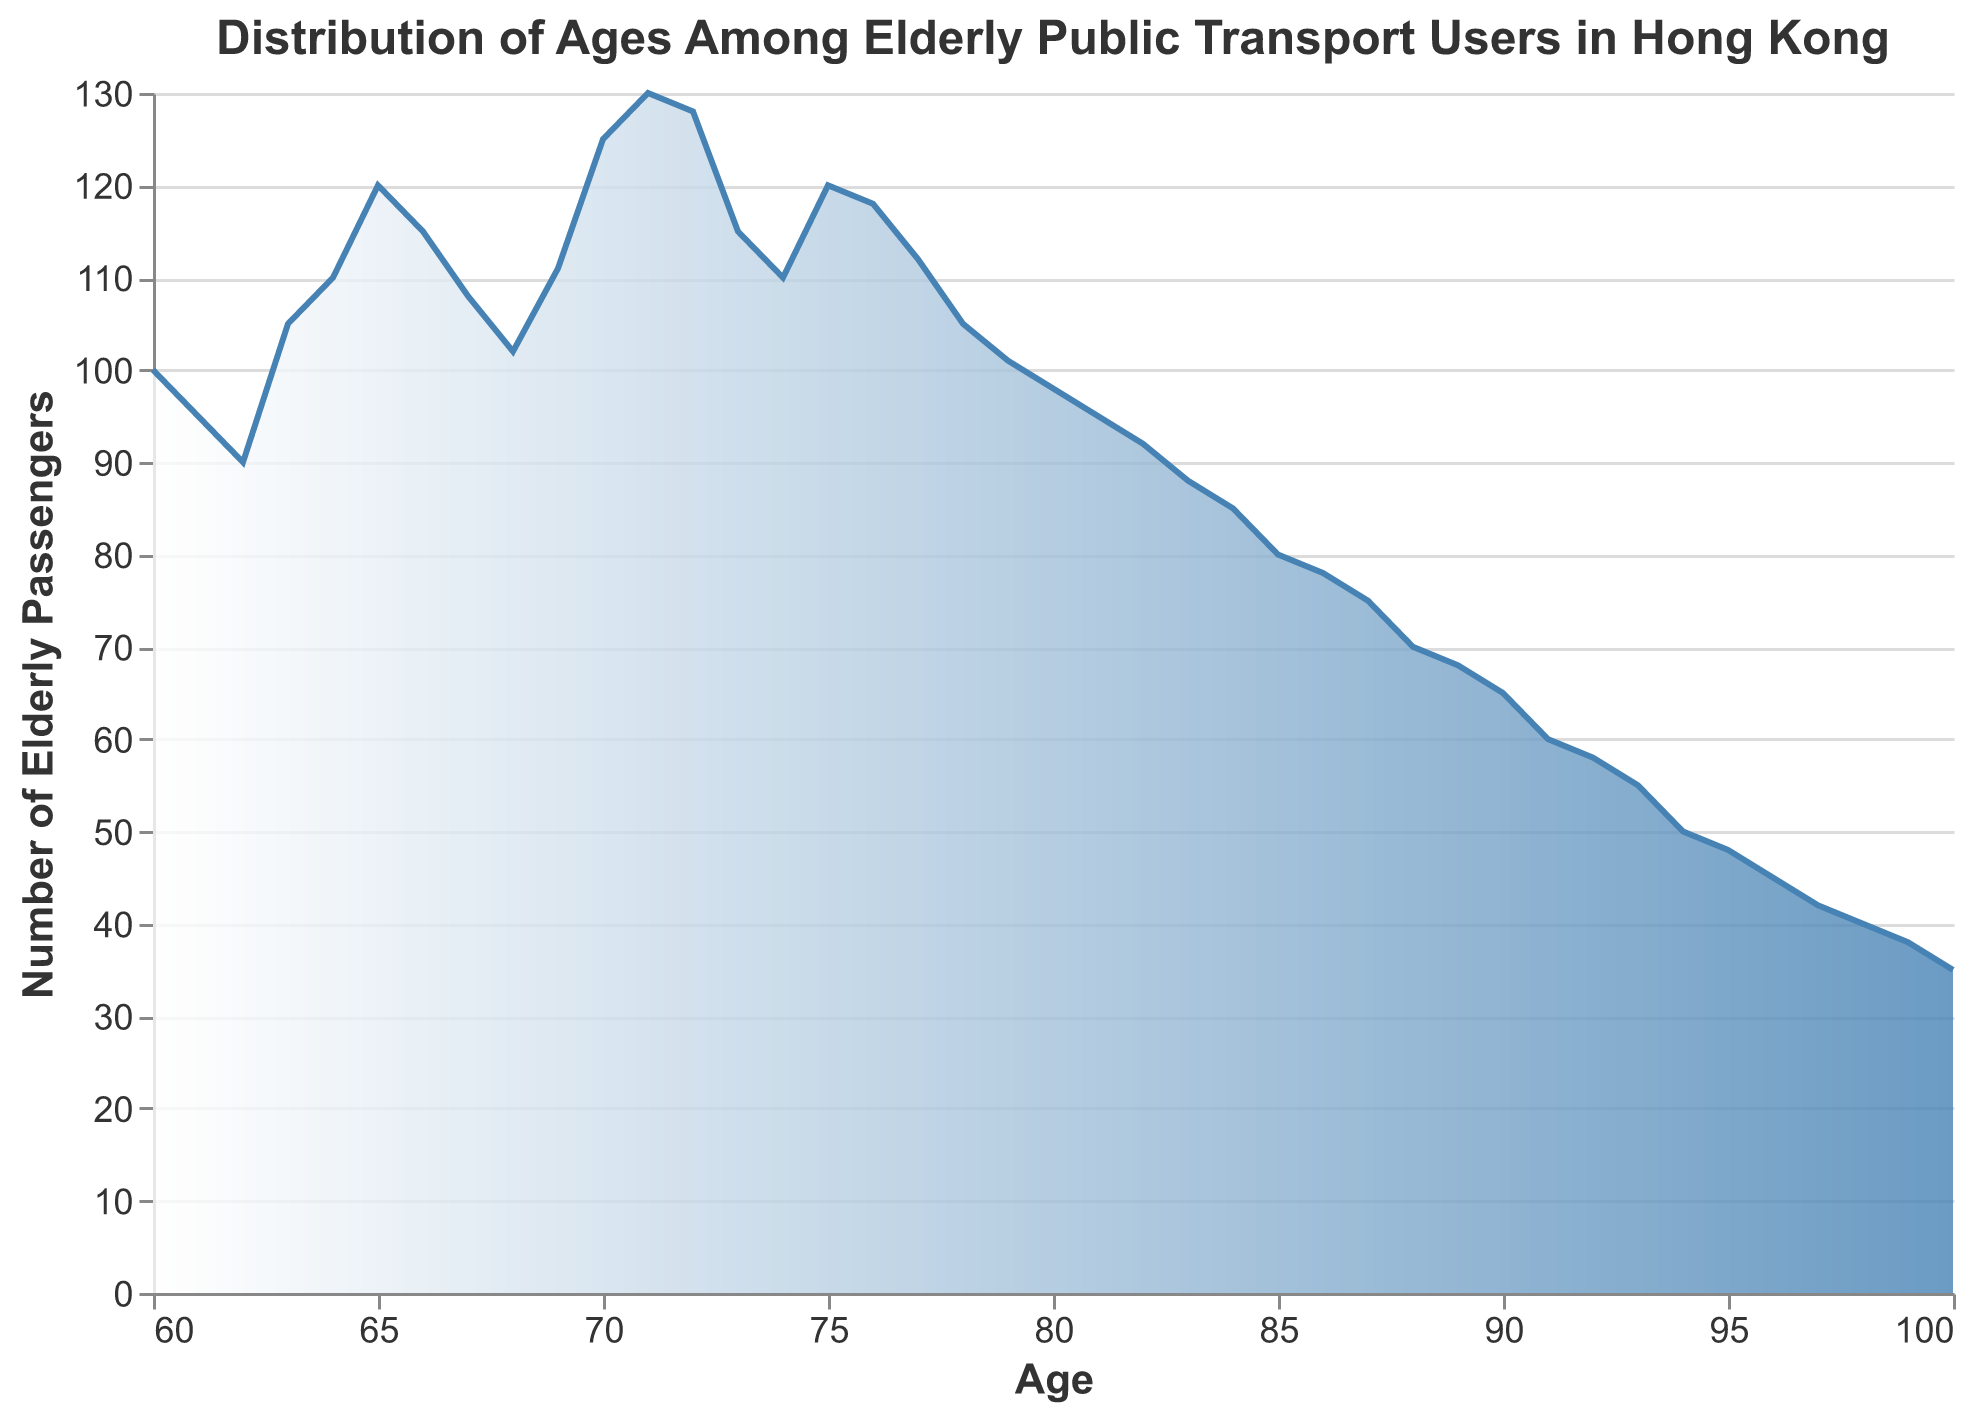What is the title of the plot? The title of the plot is written at the top and serves as a summary of what the plot illustrates.
Answer: Distribution of Ages Among Elderly Public Transport Users in Hong Kong What is the age range of elderly passengers in the plot? The x-axis represents the age of elderly passengers. The minimum value is 60, and the maximum value is 100.
Answer: 60 to 100 Which age group has the highest number of elderly passengers using public transportation? By observing the peak of the density curve on the y-axis, we can see the age group with the highest number of passengers.
Answer: 71 At what age does the number of elderly passengers first fall below 60? The number of elderly passengers is shown on the y-axis. Locate the point where it falls below 60 on the curve corresponds to the age on the x-axis.
Answer: 91 How many elderly passengers are there at the age of 80? Find the age 80 on the x-axis and locate the corresponding value on the y-axis.
Answer: 98 Which age group has fewer than 50 elderly passengers using public transport for the first time? Find the point on the curve where the number of elderly passengers first drops below 50. The x-axis value at this point indicates the age group.
Answer: 93 How does the number of passengers change as age increases from 60 to 71? Examine the shape of the density curve from age 60 to 71. Notice whether the curve rises or falls.
Answer: It increases steadily, reaching a peak at 71 What is the average number of elderly passengers between age 65 and 75? Calculate the sum of the number of passengers from age 65 to age 75 and divide by the number of age points (11).
Answer: 118.72 Compare the number of elderly passengers at age 70 and age 90. Look at the values corresponding to age 70 and age 90 on the y-axis, then compare them.
Answer: 125 at age 70, 65 at age 90 Describe the overall trend in the number of elderly passengers as they age from 60 to 100. Evaluate whether the number of passengers increases or decreases as the age progresses by observing the trend of the density curve.
Answer: Generally decreases after peaking at 71 